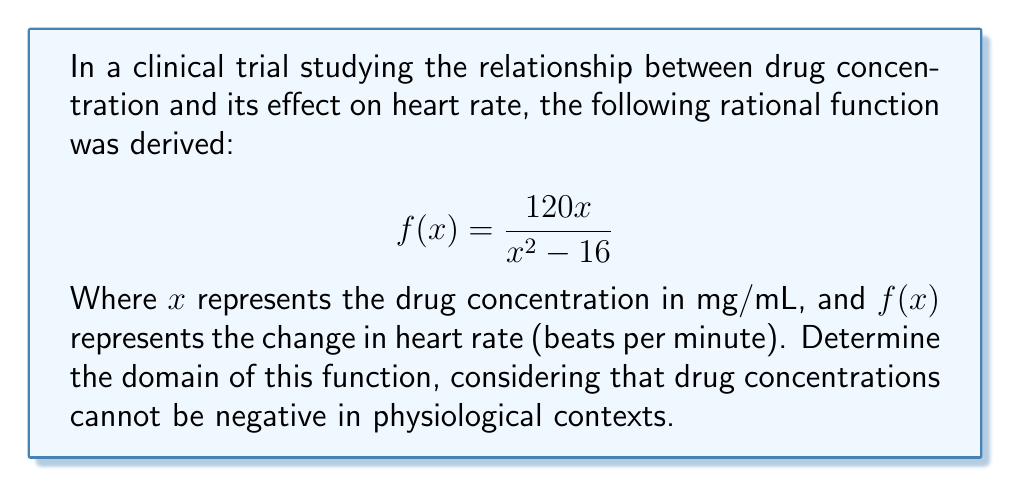Give your solution to this math problem. To determine the domain of this rational function, we need to follow these steps:

1) First, recall that the domain of a rational function includes all real numbers except those that make the denominator equal to zero.

2) Set the denominator equal to zero and solve for x:
   $$x^2 - 16 = 0$$
   $$(x+4)(x-4) = 0$$
   $$x = -4 \text{ or } x = 4$$

3) These values of x would make the denominator zero, so they must be excluded from the domain.

4) However, we also need to consider the physiological context. Drug concentrations cannot be negative, so we must exclude all negative values of x.

5) Therefore, the domain will be all positive real numbers, except for 4.

6) In interval notation, this can be written as:
   $$(0,4) \cup (4,\infty)$$

This means the function is defined for all positive real numbers greater than 0 and less than 4, and all real numbers greater than 4.
Answer: $(0,4) \cup (4,\infty)$ 